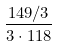<formula> <loc_0><loc_0><loc_500><loc_500>\frac { 1 4 9 / 3 } { 3 \cdot 1 1 8 }</formula> 